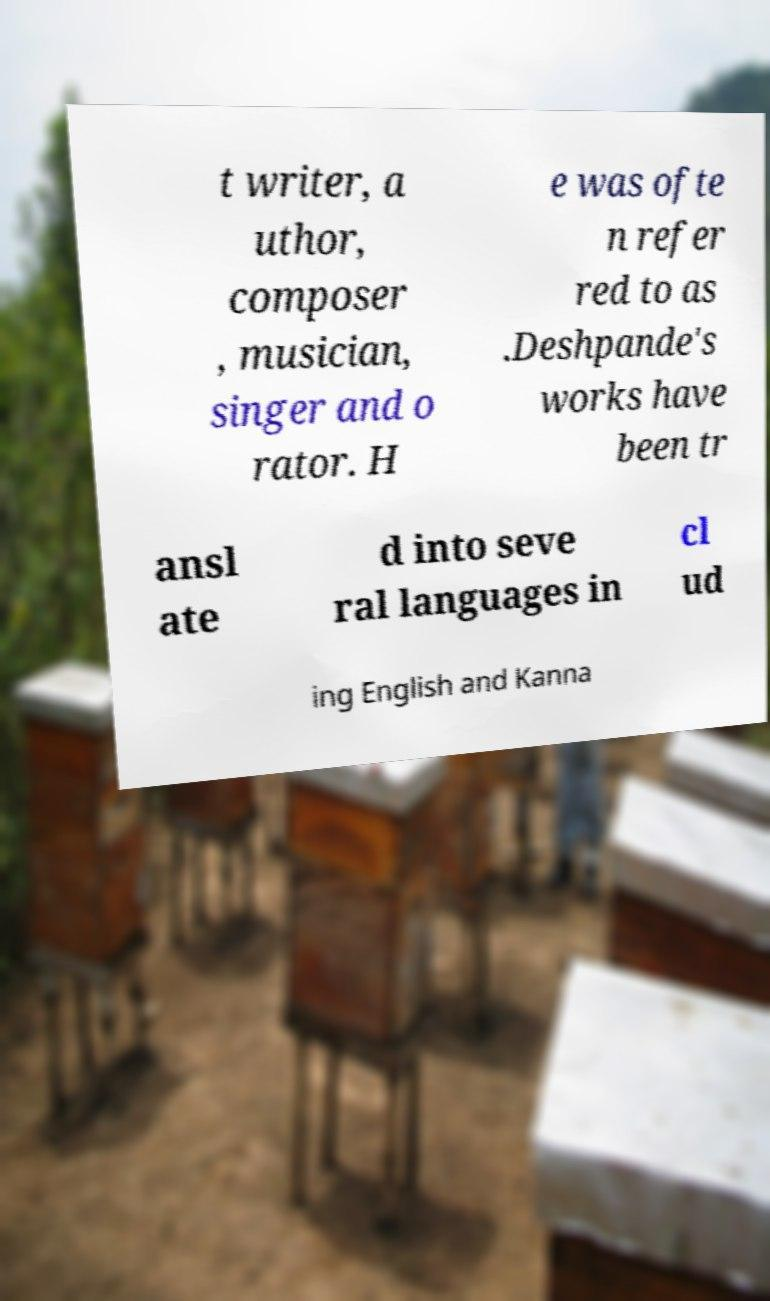For documentation purposes, I need the text within this image transcribed. Could you provide that? t writer, a uthor, composer , musician, singer and o rator. H e was ofte n refer red to as .Deshpande's works have been tr ansl ate d into seve ral languages in cl ud ing English and Kanna 